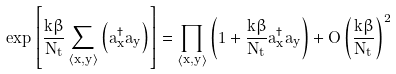<formula> <loc_0><loc_0><loc_500><loc_500>\exp \left [ \frac { k \beta } { N _ { t } } \sum _ { \left < x , y \right > } \left ( a ^ { \dagger } _ { x } a _ { y } \right ) \right ] = \prod _ { \left < x , y \right > } \left ( 1 + \frac { k \beta } { N _ { t } } a ^ { \dagger } _ { x } a _ { y } \right ) + O \left ( \frac { k \beta } { N _ { t } } \right ) ^ { 2 }</formula> 